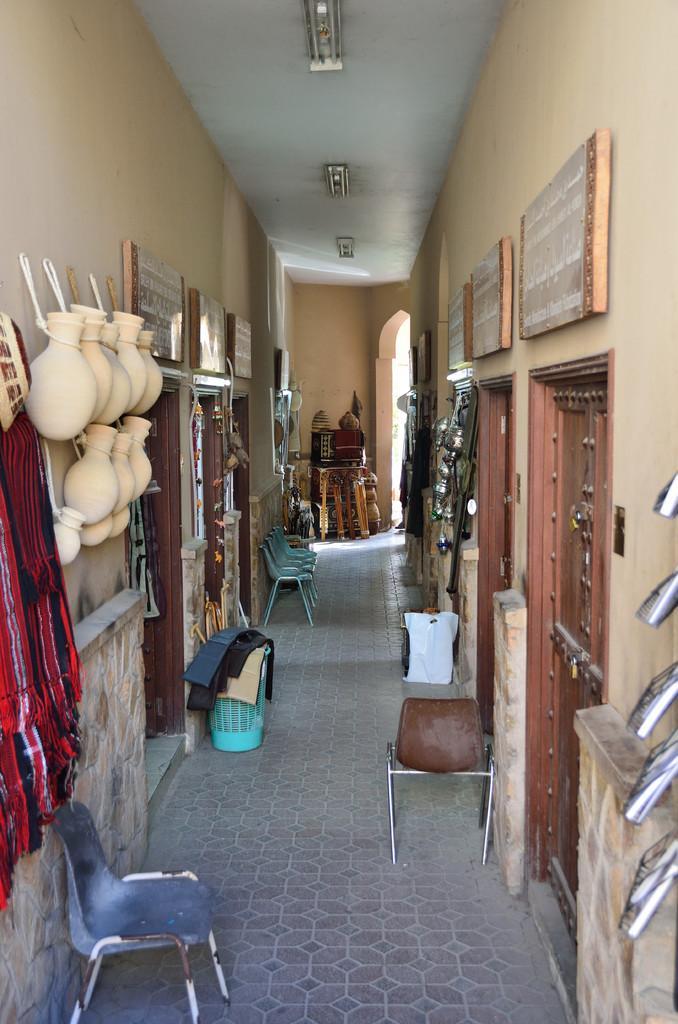Could you give a brief overview of what you see in this image? In the foreground of this picture, there are chairs, baskets are placed side on the path and few objects like, pots, clothes, doors, are on either side to the path. In the background, there are few objects. On the top, there are lights. 